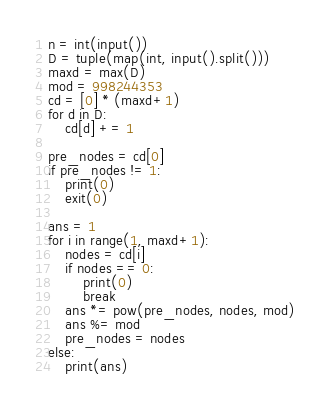Convert code to text. <code><loc_0><loc_0><loc_500><loc_500><_Python_>n = int(input())
D = tuple(map(int, input().split()))
maxd = max(D)
mod = 998244353
cd = [0] * (maxd+1)
for d in D:
    cd[d] += 1

pre_nodes = cd[0]
if pre_nodes != 1:
    print(0)
    exit(0)

ans = 1
for i in range(1, maxd+1):
    nodes = cd[i]
    if nodes == 0:
        print(0)
        break
    ans *= pow(pre_nodes, nodes, mod)
    ans %= mod
    pre_nodes = nodes
else:
    print(ans)
</code> 